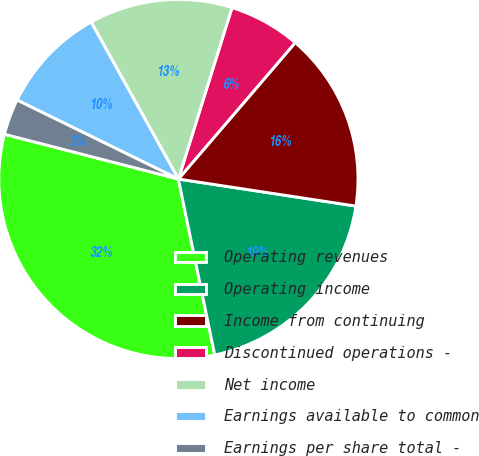<chart> <loc_0><loc_0><loc_500><loc_500><pie_chart><fcel>Operating revenues<fcel>Operating income<fcel>Income from continuing<fcel>Discontinued operations -<fcel>Net income<fcel>Earnings available to common<fcel>Earnings per share total -<nl><fcel>32.26%<fcel>19.35%<fcel>16.13%<fcel>6.45%<fcel>12.9%<fcel>9.68%<fcel>3.23%<nl></chart> 